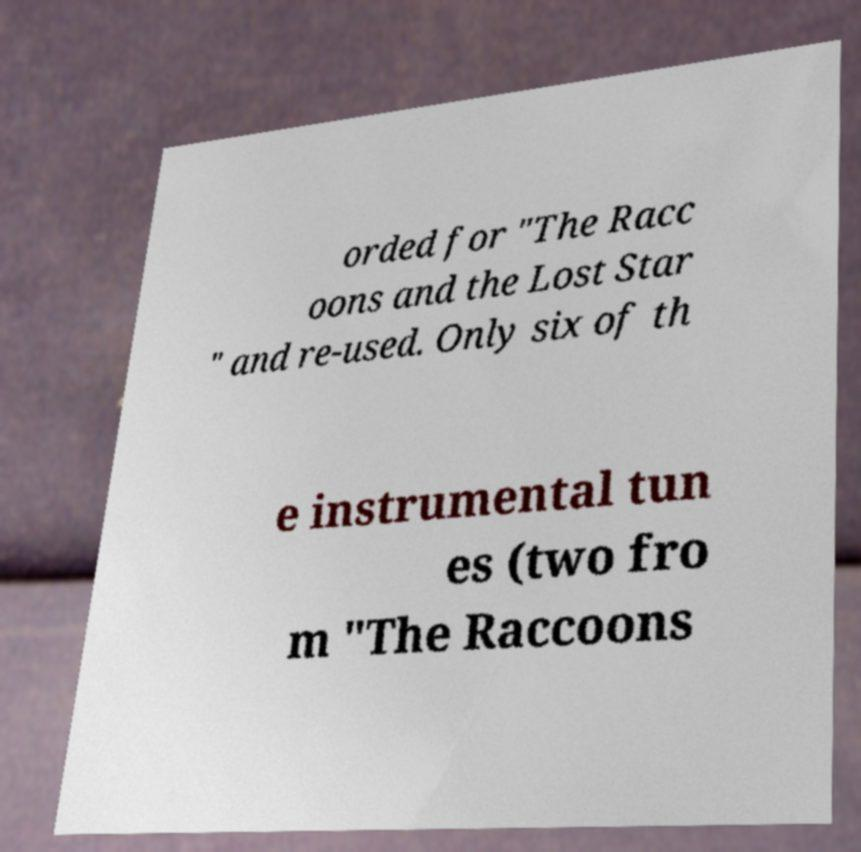I need the written content from this picture converted into text. Can you do that? orded for "The Racc oons and the Lost Star " and re-used. Only six of th e instrumental tun es (two fro m "The Raccoons 